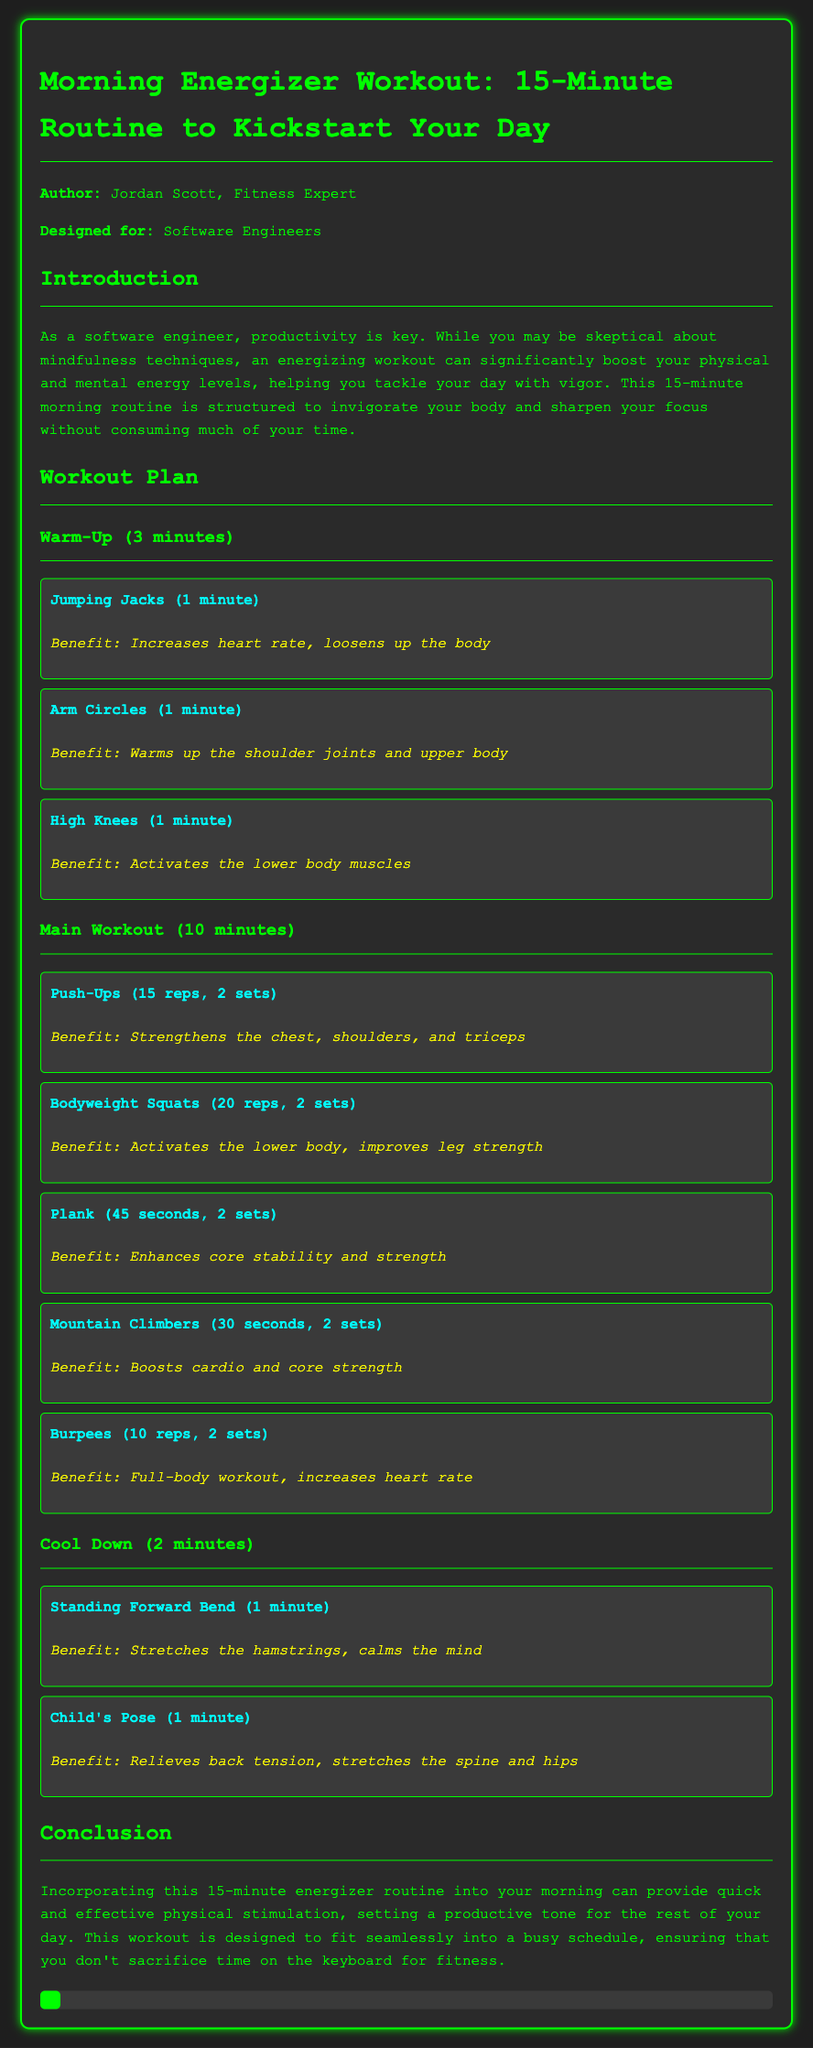what is the title of the workout plan? The title of the workout plan is mentioned at the top of the document.
Answer: Morning Energizer Workout: 15-Minute Routine to Kickstart Your Day who is the author of the workout plan? The author's name is provided in the introduction section of the document.
Answer: Jordan Scott how long is the warm-up section? The duration of the warm-up section is stated in the workout plan.
Answer: 3 minutes what is the first exercise listed in the main workout? The first exercise in the main workout section is clearly highlighted.
Answer: Push-Ups how many repetitions are recommended for burpees? The number of repetitions for burpees is specified in the main workout section.
Answer: 10 reps what is the benefit of the child's pose exercise? The benefit of the child's pose is mentioned alongside the exercise in the cool down section.
Answer: Relieves back tension, stretches the spine and hips what type of workout is described in this document? The overall type of workout is indicated in the title and introduction of the document.
Answer: Workout plan how many sets are suggested for high knees? The number of sets is not explicitly mentioned, but it falls under the warm-up section.
Answer: 1 set 